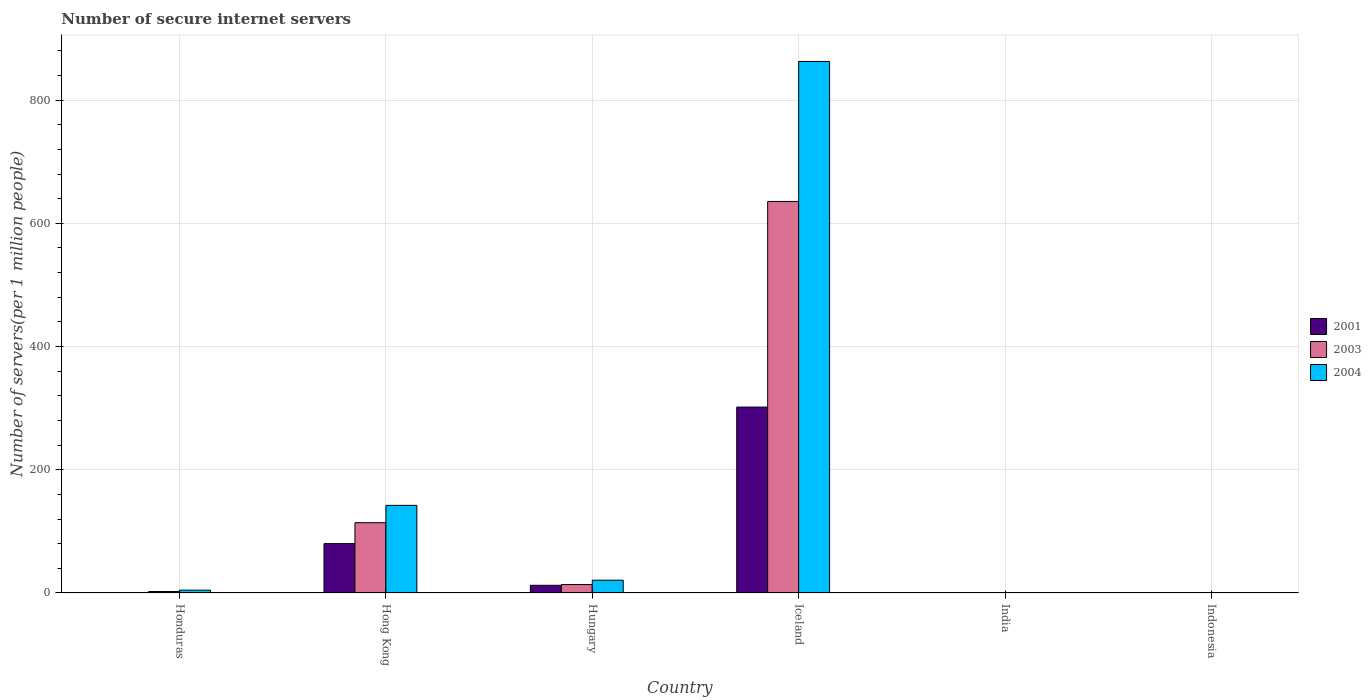Are the number of bars per tick equal to the number of legend labels?
Make the answer very short. Yes. How many bars are there on the 6th tick from the right?
Ensure brevity in your answer.  3. What is the label of the 1st group of bars from the left?
Offer a very short reply. Honduras. In how many cases, is the number of bars for a given country not equal to the number of legend labels?
Your response must be concise. 0. What is the number of secure internet servers in 2003 in Iceland?
Offer a terse response. 635.53. Across all countries, what is the maximum number of secure internet servers in 2004?
Your answer should be very brief. 862.8. Across all countries, what is the minimum number of secure internet servers in 2003?
Your response must be concise. 0.25. In which country was the number of secure internet servers in 2001 minimum?
Provide a short and direct response. India. What is the total number of secure internet servers in 2003 in the graph?
Offer a very short reply. 766.3. What is the difference between the number of secure internet servers in 2004 in Honduras and that in Iceland?
Your response must be concise. -858.2. What is the difference between the number of secure internet servers in 2004 in Hungary and the number of secure internet servers in 2001 in Iceland?
Offer a very short reply. -281.01. What is the average number of secure internet servers in 2001 per country?
Give a very brief answer. 65.9. What is the difference between the number of secure internet servers of/in 2001 and number of secure internet servers of/in 2003 in Indonesia?
Your answer should be compact. 0.01. What is the ratio of the number of secure internet servers in 2003 in Hungary to that in India?
Keep it short and to the point. 54.13. What is the difference between the highest and the second highest number of secure internet servers in 2004?
Provide a short and direct response. 121.48. What is the difference between the highest and the lowest number of secure internet servers in 2003?
Ensure brevity in your answer.  635.28. In how many countries, is the number of secure internet servers in 2001 greater than the average number of secure internet servers in 2001 taken over all countries?
Ensure brevity in your answer.  2. What does the 3rd bar from the right in India represents?
Ensure brevity in your answer.  2001. Is it the case that in every country, the sum of the number of secure internet servers in 2003 and number of secure internet servers in 2001 is greater than the number of secure internet servers in 2004?
Provide a succinct answer. No. What is the difference between two consecutive major ticks on the Y-axis?
Keep it short and to the point. 200. Are the values on the major ticks of Y-axis written in scientific E-notation?
Your response must be concise. No. Does the graph contain any zero values?
Offer a terse response. No. What is the title of the graph?
Provide a succinct answer. Number of secure internet servers. Does "1995" appear as one of the legend labels in the graph?
Your answer should be compact. No. What is the label or title of the X-axis?
Give a very brief answer. Country. What is the label or title of the Y-axis?
Offer a very short reply. Number of servers(per 1 million people). What is the Number of servers(per 1 million people) in 2001 in Honduras?
Your answer should be compact. 0.63. What is the Number of servers(per 1 million people) of 2003 in Honduras?
Ensure brevity in your answer.  2.41. What is the Number of servers(per 1 million people) of 2004 in Honduras?
Your answer should be compact. 4.59. What is the Number of servers(per 1 million people) of 2001 in Hong Kong?
Provide a short and direct response. 80.13. What is the Number of servers(per 1 million people) of 2003 in Hong Kong?
Give a very brief answer. 114.1. What is the Number of servers(per 1 million people) in 2004 in Hong Kong?
Provide a short and direct response. 142.26. What is the Number of servers(per 1 million people) of 2001 in Hungary?
Ensure brevity in your answer.  12.47. What is the Number of servers(per 1 million people) in 2003 in Hungary?
Give a very brief answer. 13.72. What is the Number of servers(per 1 million people) of 2004 in Hungary?
Keep it short and to the point. 20.78. What is the Number of servers(per 1 million people) of 2001 in Iceland?
Keep it short and to the point. 301.79. What is the Number of servers(per 1 million people) of 2003 in Iceland?
Your answer should be very brief. 635.53. What is the Number of servers(per 1 million people) in 2004 in Iceland?
Your answer should be compact. 862.8. What is the Number of servers(per 1 million people) in 2001 in India?
Your answer should be very brief. 0.11. What is the Number of servers(per 1 million people) of 2003 in India?
Your answer should be compact. 0.25. What is the Number of servers(per 1 million people) in 2004 in India?
Provide a succinct answer. 0.41. What is the Number of servers(per 1 million people) of 2001 in Indonesia?
Your answer should be very brief. 0.28. What is the Number of servers(per 1 million people) in 2003 in Indonesia?
Keep it short and to the point. 0.27. What is the Number of servers(per 1 million people) of 2004 in Indonesia?
Make the answer very short. 0.38. Across all countries, what is the maximum Number of servers(per 1 million people) in 2001?
Your answer should be compact. 301.79. Across all countries, what is the maximum Number of servers(per 1 million people) in 2003?
Your response must be concise. 635.53. Across all countries, what is the maximum Number of servers(per 1 million people) in 2004?
Give a very brief answer. 862.8. Across all countries, what is the minimum Number of servers(per 1 million people) of 2001?
Your answer should be very brief. 0.11. Across all countries, what is the minimum Number of servers(per 1 million people) of 2003?
Ensure brevity in your answer.  0.25. Across all countries, what is the minimum Number of servers(per 1 million people) of 2004?
Provide a succinct answer. 0.38. What is the total Number of servers(per 1 million people) of 2001 in the graph?
Provide a short and direct response. 395.4. What is the total Number of servers(per 1 million people) of 2003 in the graph?
Your answer should be compact. 766.3. What is the total Number of servers(per 1 million people) in 2004 in the graph?
Your response must be concise. 1031.21. What is the difference between the Number of servers(per 1 million people) in 2001 in Honduras and that in Hong Kong?
Your answer should be very brief. -79.5. What is the difference between the Number of servers(per 1 million people) in 2003 in Honduras and that in Hong Kong?
Offer a very short reply. -111.69. What is the difference between the Number of servers(per 1 million people) of 2004 in Honduras and that in Hong Kong?
Keep it short and to the point. -137.67. What is the difference between the Number of servers(per 1 million people) of 2001 in Honduras and that in Hungary?
Your answer should be very brief. -11.84. What is the difference between the Number of servers(per 1 million people) in 2003 in Honduras and that in Hungary?
Make the answer very short. -11.31. What is the difference between the Number of servers(per 1 million people) in 2004 in Honduras and that in Hungary?
Your answer should be very brief. -16.19. What is the difference between the Number of servers(per 1 million people) in 2001 in Honduras and that in Iceland?
Provide a short and direct response. -301.16. What is the difference between the Number of servers(per 1 million people) of 2003 in Honduras and that in Iceland?
Offer a very short reply. -633.12. What is the difference between the Number of servers(per 1 million people) in 2004 in Honduras and that in Iceland?
Offer a very short reply. -858.2. What is the difference between the Number of servers(per 1 million people) of 2001 in Honduras and that in India?
Offer a very short reply. 0.51. What is the difference between the Number of servers(per 1 million people) in 2003 in Honduras and that in India?
Provide a short and direct response. 2.16. What is the difference between the Number of servers(per 1 million people) of 2004 in Honduras and that in India?
Your answer should be very brief. 4.18. What is the difference between the Number of servers(per 1 million people) of 2001 in Honduras and that in Indonesia?
Offer a terse response. 0.35. What is the difference between the Number of servers(per 1 million people) in 2003 in Honduras and that in Indonesia?
Offer a very short reply. 2.14. What is the difference between the Number of servers(per 1 million people) in 2004 in Honduras and that in Indonesia?
Give a very brief answer. 4.21. What is the difference between the Number of servers(per 1 million people) of 2001 in Hong Kong and that in Hungary?
Your response must be concise. 67.66. What is the difference between the Number of servers(per 1 million people) of 2003 in Hong Kong and that in Hungary?
Keep it short and to the point. 100.38. What is the difference between the Number of servers(per 1 million people) in 2004 in Hong Kong and that in Hungary?
Provide a short and direct response. 121.48. What is the difference between the Number of servers(per 1 million people) in 2001 in Hong Kong and that in Iceland?
Make the answer very short. -221.66. What is the difference between the Number of servers(per 1 million people) of 2003 in Hong Kong and that in Iceland?
Offer a terse response. -521.43. What is the difference between the Number of servers(per 1 million people) in 2004 in Hong Kong and that in Iceland?
Make the answer very short. -720.54. What is the difference between the Number of servers(per 1 million people) in 2001 in Hong Kong and that in India?
Offer a very short reply. 80.01. What is the difference between the Number of servers(per 1 million people) in 2003 in Hong Kong and that in India?
Your response must be concise. 113.85. What is the difference between the Number of servers(per 1 million people) of 2004 in Hong Kong and that in India?
Your answer should be compact. 141.85. What is the difference between the Number of servers(per 1 million people) of 2001 in Hong Kong and that in Indonesia?
Your response must be concise. 79.85. What is the difference between the Number of servers(per 1 million people) of 2003 in Hong Kong and that in Indonesia?
Offer a very short reply. 113.83. What is the difference between the Number of servers(per 1 million people) of 2004 in Hong Kong and that in Indonesia?
Provide a short and direct response. 141.88. What is the difference between the Number of servers(per 1 million people) of 2001 in Hungary and that in Iceland?
Offer a terse response. -289.32. What is the difference between the Number of servers(per 1 million people) in 2003 in Hungary and that in Iceland?
Keep it short and to the point. -621.81. What is the difference between the Number of servers(per 1 million people) of 2004 in Hungary and that in Iceland?
Make the answer very short. -842.02. What is the difference between the Number of servers(per 1 million people) in 2001 in Hungary and that in India?
Offer a terse response. 12.35. What is the difference between the Number of servers(per 1 million people) in 2003 in Hungary and that in India?
Ensure brevity in your answer.  13.47. What is the difference between the Number of servers(per 1 million people) of 2004 in Hungary and that in India?
Offer a terse response. 20.37. What is the difference between the Number of servers(per 1 million people) in 2001 in Hungary and that in Indonesia?
Offer a terse response. 12.19. What is the difference between the Number of servers(per 1 million people) of 2003 in Hungary and that in Indonesia?
Your response must be concise. 13.45. What is the difference between the Number of servers(per 1 million people) of 2004 in Hungary and that in Indonesia?
Make the answer very short. 20.4. What is the difference between the Number of servers(per 1 million people) in 2001 in Iceland and that in India?
Give a very brief answer. 301.67. What is the difference between the Number of servers(per 1 million people) of 2003 in Iceland and that in India?
Ensure brevity in your answer.  635.28. What is the difference between the Number of servers(per 1 million people) of 2004 in Iceland and that in India?
Ensure brevity in your answer.  862.38. What is the difference between the Number of servers(per 1 million people) of 2001 in Iceland and that in Indonesia?
Your answer should be compact. 301.51. What is the difference between the Number of servers(per 1 million people) of 2003 in Iceland and that in Indonesia?
Ensure brevity in your answer.  635.26. What is the difference between the Number of servers(per 1 million people) in 2004 in Iceland and that in Indonesia?
Your answer should be very brief. 862.41. What is the difference between the Number of servers(per 1 million people) of 2001 in India and that in Indonesia?
Offer a very short reply. -0.17. What is the difference between the Number of servers(per 1 million people) in 2003 in India and that in Indonesia?
Your response must be concise. -0.02. What is the difference between the Number of servers(per 1 million people) in 2004 in India and that in Indonesia?
Offer a very short reply. 0.03. What is the difference between the Number of servers(per 1 million people) in 2001 in Honduras and the Number of servers(per 1 million people) in 2003 in Hong Kong?
Your response must be concise. -113.47. What is the difference between the Number of servers(per 1 million people) of 2001 in Honduras and the Number of servers(per 1 million people) of 2004 in Hong Kong?
Ensure brevity in your answer.  -141.63. What is the difference between the Number of servers(per 1 million people) in 2003 in Honduras and the Number of servers(per 1 million people) in 2004 in Hong Kong?
Provide a short and direct response. -139.84. What is the difference between the Number of servers(per 1 million people) of 2001 in Honduras and the Number of servers(per 1 million people) of 2003 in Hungary?
Give a very brief answer. -13.09. What is the difference between the Number of servers(per 1 million people) of 2001 in Honduras and the Number of servers(per 1 million people) of 2004 in Hungary?
Provide a short and direct response. -20.15. What is the difference between the Number of servers(per 1 million people) in 2003 in Honduras and the Number of servers(per 1 million people) in 2004 in Hungary?
Keep it short and to the point. -18.36. What is the difference between the Number of servers(per 1 million people) of 2001 in Honduras and the Number of servers(per 1 million people) of 2003 in Iceland?
Offer a very short reply. -634.9. What is the difference between the Number of servers(per 1 million people) of 2001 in Honduras and the Number of servers(per 1 million people) of 2004 in Iceland?
Offer a terse response. -862.17. What is the difference between the Number of servers(per 1 million people) of 2003 in Honduras and the Number of servers(per 1 million people) of 2004 in Iceland?
Provide a short and direct response. -860.38. What is the difference between the Number of servers(per 1 million people) of 2001 in Honduras and the Number of servers(per 1 million people) of 2003 in India?
Make the answer very short. 0.37. What is the difference between the Number of servers(per 1 million people) of 2001 in Honduras and the Number of servers(per 1 million people) of 2004 in India?
Provide a succinct answer. 0.22. What is the difference between the Number of servers(per 1 million people) of 2003 in Honduras and the Number of servers(per 1 million people) of 2004 in India?
Give a very brief answer. 2. What is the difference between the Number of servers(per 1 million people) in 2001 in Honduras and the Number of servers(per 1 million people) in 2003 in Indonesia?
Your answer should be very brief. 0.36. What is the difference between the Number of servers(per 1 million people) in 2001 in Honduras and the Number of servers(per 1 million people) in 2004 in Indonesia?
Offer a very short reply. 0.25. What is the difference between the Number of servers(per 1 million people) in 2003 in Honduras and the Number of servers(per 1 million people) in 2004 in Indonesia?
Provide a short and direct response. 2.03. What is the difference between the Number of servers(per 1 million people) in 2001 in Hong Kong and the Number of servers(per 1 million people) in 2003 in Hungary?
Provide a succinct answer. 66.41. What is the difference between the Number of servers(per 1 million people) in 2001 in Hong Kong and the Number of servers(per 1 million people) in 2004 in Hungary?
Provide a succinct answer. 59.35. What is the difference between the Number of servers(per 1 million people) in 2003 in Hong Kong and the Number of servers(per 1 million people) in 2004 in Hungary?
Your answer should be very brief. 93.33. What is the difference between the Number of servers(per 1 million people) in 2001 in Hong Kong and the Number of servers(per 1 million people) in 2003 in Iceland?
Your response must be concise. -555.4. What is the difference between the Number of servers(per 1 million people) of 2001 in Hong Kong and the Number of servers(per 1 million people) of 2004 in Iceland?
Make the answer very short. -782.67. What is the difference between the Number of servers(per 1 million people) in 2003 in Hong Kong and the Number of servers(per 1 million people) in 2004 in Iceland?
Ensure brevity in your answer.  -748.69. What is the difference between the Number of servers(per 1 million people) of 2001 in Hong Kong and the Number of servers(per 1 million people) of 2003 in India?
Provide a short and direct response. 79.87. What is the difference between the Number of servers(per 1 million people) in 2001 in Hong Kong and the Number of servers(per 1 million people) in 2004 in India?
Offer a very short reply. 79.72. What is the difference between the Number of servers(per 1 million people) of 2003 in Hong Kong and the Number of servers(per 1 million people) of 2004 in India?
Provide a succinct answer. 113.69. What is the difference between the Number of servers(per 1 million people) of 2001 in Hong Kong and the Number of servers(per 1 million people) of 2003 in Indonesia?
Make the answer very short. 79.86. What is the difference between the Number of servers(per 1 million people) in 2001 in Hong Kong and the Number of servers(per 1 million people) in 2004 in Indonesia?
Make the answer very short. 79.75. What is the difference between the Number of servers(per 1 million people) of 2003 in Hong Kong and the Number of servers(per 1 million people) of 2004 in Indonesia?
Make the answer very short. 113.72. What is the difference between the Number of servers(per 1 million people) in 2001 in Hungary and the Number of servers(per 1 million people) in 2003 in Iceland?
Offer a terse response. -623.07. What is the difference between the Number of servers(per 1 million people) in 2001 in Hungary and the Number of servers(per 1 million people) in 2004 in Iceland?
Keep it short and to the point. -850.33. What is the difference between the Number of servers(per 1 million people) of 2003 in Hungary and the Number of servers(per 1 million people) of 2004 in Iceland?
Offer a terse response. -849.07. What is the difference between the Number of servers(per 1 million people) of 2001 in Hungary and the Number of servers(per 1 million people) of 2003 in India?
Provide a short and direct response. 12.21. What is the difference between the Number of servers(per 1 million people) in 2001 in Hungary and the Number of servers(per 1 million people) in 2004 in India?
Keep it short and to the point. 12.06. What is the difference between the Number of servers(per 1 million people) of 2003 in Hungary and the Number of servers(per 1 million people) of 2004 in India?
Give a very brief answer. 13.31. What is the difference between the Number of servers(per 1 million people) of 2001 in Hungary and the Number of servers(per 1 million people) of 2003 in Indonesia?
Keep it short and to the point. 12.19. What is the difference between the Number of servers(per 1 million people) in 2001 in Hungary and the Number of servers(per 1 million people) in 2004 in Indonesia?
Ensure brevity in your answer.  12.09. What is the difference between the Number of servers(per 1 million people) of 2003 in Hungary and the Number of servers(per 1 million people) of 2004 in Indonesia?
Your answer should be very brief. 13.34. What is the difference between the Number of servers(per 1 million people) of 2001 in Iceland and the Number of servers(per 1 million people) of 2003 in India?
Ensure brevity in your answer.  301.53. What is the difference between the Number of servers(per 1 million people) of 2001 in Iceland and the Number of servers(per 1 million people) of 2004 in India?
Make the answer very short. 301.38. What is the difference between the Number of servers(per 1 million people) in 2003 in Iceland and the Number of servers(per 1 million people) in 2004 in India?
Ensure brevity in your answer.  635.12. What is the difference between the Number of servers(per 1 million people) in 2001 in Iceland and the Number of servers(per 1 million people) in 2003 in Indonesia?
Ensure brevity in your answer.  301.52. What is the difference between the Number of servers(per 1 million people) in 2001 in Iceland and the Number of servers(per 1 million people) in 2004 in Indonesia?
Your answer should be compact. 301.41. What is the difference between the Number of servers(per 1 million people) of 2003 in Iceland and the Number of servers(per 1 million people) of 2004 in Indonesia?
Your answer should be compact. 635.15. What is the difference between the Number of servers(per 1 million people) of 2001 in India and the Number of servers(per 1 million people) of 2003 in Indonesia?
Your response must be concise. -0.16. What is the difference between the Number of servers(per 1 million people) in 2001 in India and the Number of servers(per 1 million people) in 2004 in Indonesia?
Offer a terse response. -0.27. What is the difference between the Number of servers(per 1 million people) of 2003 in India and the Number of servers(per 1 million people) of 2004 in Indonesia?
Your answer should be very brief. -0.13. What is the average Number of servers(per 1 million people) of 2001 per country?
Make the answer very short. 65.9. What is the average Number of servers(per 1 million people) in 2003 per country?
Offer a very short reply. 127.72. What is the average Number of servers(per 1 million people) in 2004 per country?
Your response must be concise. 171.87. What is the difference between the Number of servers(per 1 million people) in 2001 and Number of servers(per 1 million people) in 2003 in Honduras?
Offer a terse response. -1.79. What is the difference between the Number of servers(per 1 million people) of 2001 and Number of servers(per 1 million people) of 2004 in Honduras?
Your answer should be very brief. -3.96. What is the difference between the Number of servers(per 1 million people) of 2003 and Number of servers(per 1 million people) of 2004 in Honduras?
Ensure brevity in your answer.  -2.18. What is the difference between the Number of servers(per 1 million people) of 2001 and Number of servers(per 1 million people) of 2003 in Hong Kong?
Your answer should be compact. -33.97. What is the difference between the Number of servers(per 1 million people) in 2001 and Number of servers(per 1 million people) in 2004 in Hong Kong?
Your response must be concise. -62.13. What is the difference between the Number of servers(per 1 million people) in 2003 and Number of servers(per 1 million people) in 2004 in Hong Kong?
Provide a succinct answer. -28.15. What is the difference between the Number of servers(per 1 million people) of 2001 and Number of servers(per 1 million people) of 2003 in Hungary?
Your response must be concise. -1.26. What is the difference between the Number of servers(per 1 million people) in 2001 and Number of servers(per 1 million people) in 2004 in Hungary?
Keep it short and to the point. -8.31. What is the difference between the Number of servers(per 1 million people) of 2003 and Number of servers(per 1 million people) of 2004 in Hungary?
Provide a short and direct response. -7.06. What is the difference between the Number of servers(per 1 million people) in 2001 and Number of servers(per 1 million people) in 2003 in Iceland?
Give a very brief answer. -333.74. What is the difference between the Number of servers(per 1 million people) in 2001 and Number of servers(per 1 million people) in 2004 in Iceland?
Your answer should be very brief. -561.01. What is the difference between the Number of servers(per 1 million people) in 2003 and Number of servers(per 1 million people) in 2004 in Iceland?
Your answer should be compact. -227.26. What is the difference between the Number of servers(per 1 million people) in 2001 and Number of servers(per 1 million people) in 2003 in India?
Give a very brief answer. -0.14. What is the difference between the Number of servers(per 1 million people) in 2001 and Number of servers(per 1 million people) in 2004 in India?
Provide a short and direct response. -0.3. What is the difference between the Number of servers(per 1 million people) in 2003 and Number of servers(per 1 million people) in 2004 in India?
Provide a short and direct response. -0.16. What is the difference between the Number of servers(per 1 million people) of 2001 and Number of servers(per 1 million people) of 2003 in Indonesia?
Your response must be concise. 0.01. What is the difference between the Number of servers(per 1 million people) of 2001 and Number of servers(per 1 million people) of 2004 in Indonesia?
Offer a very short reply. -0.1. What is the difference between the Number of servers(per 1 million people) of 2003 and Number of servers(per 1 million people) of 2004 in Indonesia?
Ensure brevity in your answer.  -0.11. What is the ratio of the Number of servers(per 1 million people) in 2001 in Honduras to that in Hong Kong?
Provide a succinct answer. 0.01. What is the ratio of the Number of servers(per 1 million people) of 2003 in Honduras to that in Hong Kong?
Offer a very short reply. 0.02. What is the ratio of the Number of servers(per 1 million people) in 2004 in Honduras to that in Hong Kong?
Offer a terse response. 0.03. What is the ratio of the Number of servers(per 1 million people) in 2001 in Honduras to that in Hungary?
Keep it short and to the point. 0.05. What is the ratio of the Number of servers(per 1 million people) in 2003 in Honduras to that in Hungary?
Ensure brevity in your answer.  0.18. What is the ratio of the Number of servers(per 1 million people) in 2004 in Honduras to that in Hungary?
Offer a terse response. 0.22. What is the ratio of the Number of servers(per 1 million people) in 2001 in Honduras to that in Iceland?
Your answer should be compact. 0. What is the ratio of the Number of servers(per 1 million people) of 2003 in Honduras to that in Iceland?
Provide a short and direct response. 0. What is the ratio of the Number of servers(per 1 million people) in 2004 in Honduras to that in Iceland?
Give a very brief answer. 0.01. What is the ratio of the Number of servers(per 1 million people) of 2001 in Honduras to that in India?
Your answer should be compact. 5.52. What is the ratio of the Number of servers(per 1 million people) in 2003 in Honduras to that in India?
Ensure brevity in your answer.  9.52. What is the ratio of the Number of servers(per 1 million people) of 2004 in Honduras to that in India?
Keep it short and to the point. 11.19. What is the ratio of the Number of servers(per 1 million people) of 2001 in Honduras to that in Indonesia?
Your response must be concise. 2.24. What is the ratio of the Number of servers(per 1 million people) of 2003 in Honduras to that in Indonesia?
Offer a very short reply. 8.87. What is the ratio of the Number of servers(per 1 million people) of 2004 in Honduras to that in Indonesia?
Make the answer very short. 12.06. What is the ratio of the Number of servers(per 1 million people) in 2001 in Hong Kong to that in Hungary?
Your answer should be compact. 6.43. What is the ratio of the Number of servers(per 1 million people) in 2003 in Hong Kong to that in Hungary?
Provide a succinct answer. 8.32. What is the ratio of the Number of servers(per 1 million people) of 2004 in Hong Kong to that in Hungary?
Your answer should be compact. 6.85. What is the ratio of the Number of servers(per 1 million people) of 2001 in Hong Kong to that in Iceland?
Offer a terse response. 0.27. What is the ratio of the Number of servers(per 1 million people) in 2003 in Hong Kong to that in Iceland?
Your response must be concise. 0.18. What is the ratio of the Number of servers(per 1 million people) in 2004 in Hong Kong to that in Iceland?
Your response must be concise. 0.16. What is the ratio of the Number of servers(per 1 million people) of 2001 in Hong Kong to that in India?
Your answer should be very brief. 704. What is the ratio of the Number of servers(per 1 million people) in 2003 in Hong Kong to that in India?
Ensure brevity in your answer.  450.06. What is the ratio of the Number of servers(per 1 million people) in 2004 in Hong Kong to that in India?
Make the answer very short. 346.84. What is the ratio of the Number of servers(per 1 million people) of 2001 in Hong Kong to that in Indonesia?
Provide a short and direct response. 286.39. What is the ratio of the Number of servers(per 1 million people) in 2003 in Hong Kong to that in Indonesia?
Provide a succinct answer. 418.96. What is the ratio of the Number of servers(per 1 million people) of 2004 in Hong Kong to that in Indonesia?
Ensure brevity in your answer.  373.66. What is the ratio of the Number of servers(per 1 million people) of 2001 in Hungary to that in Iceland?
Provide a succinct answer. 0.04. What is the ratio of the Number of servers(per 1 million people) of 2003 in Hungary to that in Iceland?
Your answer should be compact. 0.02. What is the ratio of the Number of servers(per 1 million people) of 2004 in Hungary to that in Iceland?
Ensure brevity in your answer.  0.02. What is the ratio of the Number of servers(per 1 million people) in 2001 in Hungary to that in India?
Make the answer very short. 109.53. What is the ratio of the Number of servers(per 1 million people) of 2003 in Hungary to that in India?
Your answer should be very brief. 54.13. What is the ratio of the Number of servers(per 1 million people) in 2004 in Hungary to that in India?
Make the answer very short. 50.66. What is the ratio of the Number of servers(per 1 million people) in 2001 in Hungary to that in Indonesia?
Your answer should be compact. 44.56. What is the ratio of the Number of servers(per 1 million people) in 2003 in Hungary to that in Indonesia?
Keep it short and to the point. 50.39. What is the ratio of the Number of servers(per 1 million people) of 2004 in Hungary to that in Indonesia?
Offer a terse response. 54.58. What is the ratio of the Number of servers(per 1 million people) in 2001 in Iceland to that in India?
Your answer should be very brief. 2651.5. What is the ratio of the Number of servers(per 1 million people) of 2003 in Iceland to that in India?
Offer a terse response. 2506.78. What is the ratio of the Number of servers(per 1 million people) of 2004 in Iceland to that in India?
Provide a succinct answer. 2103.61. What is the ratio of the Number of servers(per 1 million people) in 2001 in Iceland to that in Indonesia?
Provide a short and direct response. 1078.63. What is the ratio of the Number of servers(per 1 million people) of 2003 in Iceland to that in Indonesia?
Provide a succinct answer. 2333.55. What is the ratio of the Number of servers(per 1 million people) of 2004 in Iceland to that in Indonesia?
Your answer should be compact. 2266.29. What is the ratio of the Number of servers(per 1 million people) of 2001 in India to that in Indonesia?
Offer a terse response. 0.41. What is the ratio of the Number of servers(per 1 million people) in 2003 in India to that in Indonesia?
Give a very brief answer. 0.93. What is the ratio of the Number of servers(per 1 million people) of 2004 in India to that in Indonesia?
Give a very brief answer. 1.08. What is the difference between the highest and the second highest Number of servers(per 1 million people) in 2001?
Ensure brevity in your answer.  221.66. What is the difference between the highest and the second highest Number of servers(per 1 million people) of 2003?
Provide a succinct answer. 521.43. What is the difference between the highest and the second highest Number of servers(per 1 million people) in 2004?
Your response must be concise. 720.54. What is the difference between the highest and the lowest Number of servers(per 1 million people) in 2001?
Offer a very short reply. 301.67. What is the difference between the highest and the lowest Number of servers(per 1 million people) of 2003?
Offer a terse response. 635.28. What is the difference between the highest and the lowest Number of servers(per 1 million people) in 2004?
Provide a succinct answer. 862.41. 